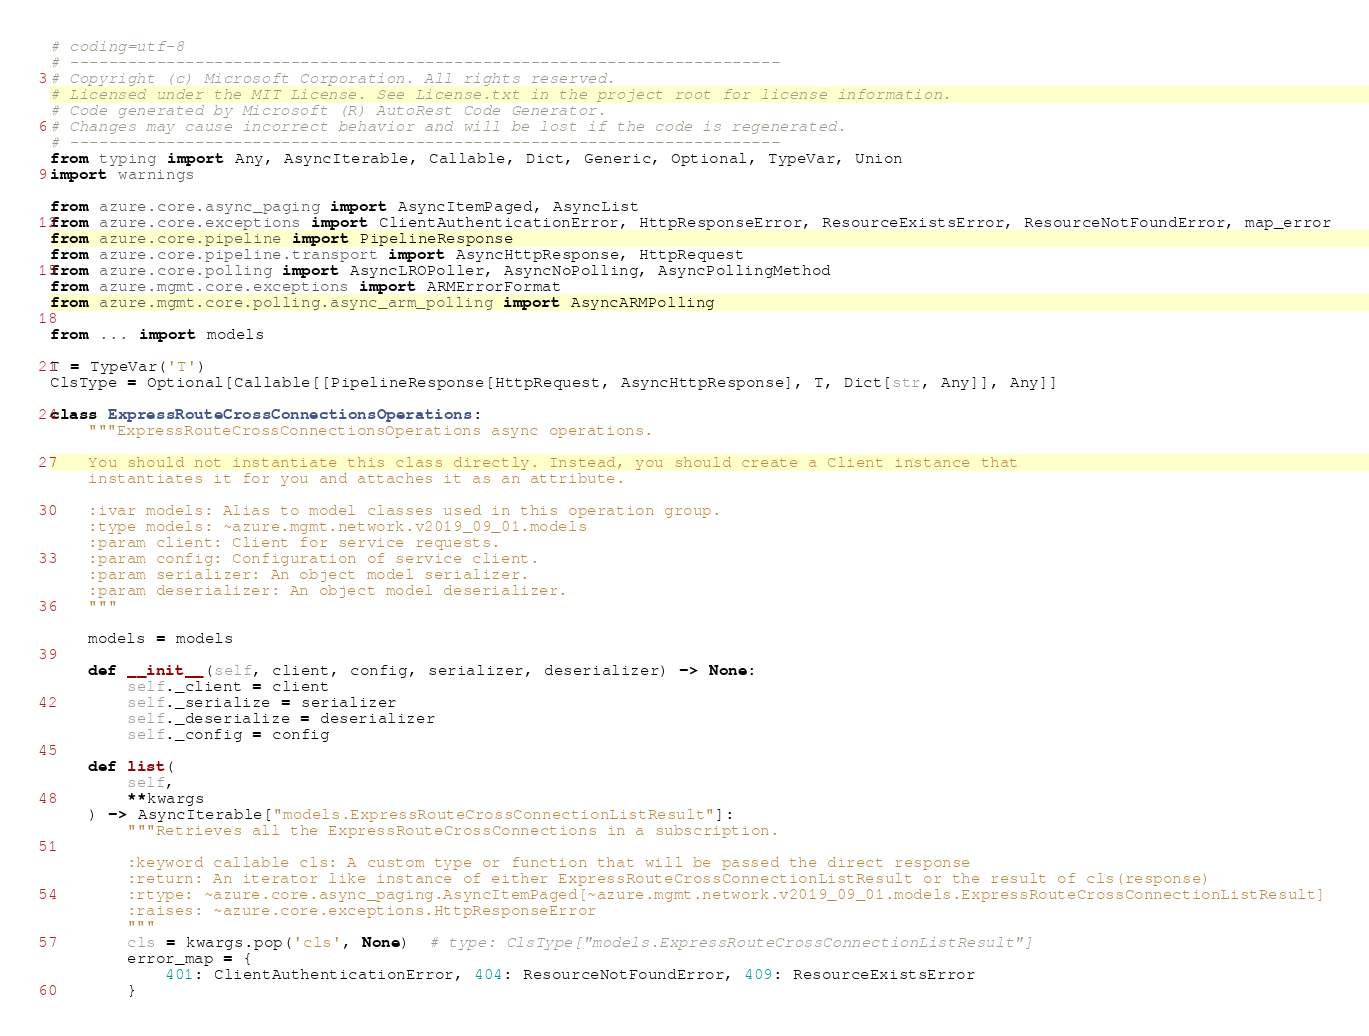<code> <loc_0><loc_0><loc_500><loc_500><_Python_># coding=utf-8
# --------------------------------------------------------------------------
# Copyright (c) Microsoft Corporation. All rights reserved.
# Licensed under the MIT License. See License.txt in the project root for license information.
# Code generated by Microsoft (R) AutoRest Code Generator.
# Changes may cause incorrect behavior and will be lost if the code is regenerated.
# --------------------------------------------------------------------------
from typing import Any, AsyncIterable, Callable, Dict, Generic, Optional, TypeVar, Union
import warnings

from azure.core.async_paging import AsyncItemPaged, AsyncList
from azure.core.exceptions import ClientAuthenticationError, HttpResponseError, ResourceExistsError, ResourceNotFoundError, map_error
from azure.core.pipeline import PipelineResponse
from azure.core.pipeline.transport import AsyncHttpResponse, HttpRequest
from azure.core.polling import AsyncLROPoller, AsyncNoPolling, AsyncPollingMethod
from azure.mgmt.core.exceptions import ARMErrorFormat
from azure.mgmt.core.polling.async_arm_polling import AsyncARMPolling

from ... import models

T = TypeVar('T')
ClsType = Optional[Callable[[PipelineResponse[HttpRequest, AsyncHttpResponse], T, Dict[str, Any]], Any]]

class ExpressRouteCrossConnectionsOperations:
    """ExpressRouteCrossConnectionsOperations async operations.

    You should not instantiate this class directly. Instead, you should create a Client instance that
    instantiates it for you and attaches it as an attribute.

    :ivar models: Alias to model classes used in this operation group.
    :type models: ~azure.mgmt.network.v2019_09_01.models
    :param client: Client for service requests.
    :param config: Configuration of service client.
    :param serializer: An object model serializer.
    :param deserializer: An object model deserializer.
    """

    models = models

    def __init__(self, client, config, serializer, deserializer) -> None:
        self._client = client
        self._serialize = serializer
        self._deserialize = deserializer
        self._config = config

    def list(
        self,
        **kwargs
    ) -> AsyncIterable["models.ExpressRouteCrossConnectionListResult"]:
        """Retrieves all the ExpressRouteCrossConnections in a subscription.

        :keyword callable cls: A custom type or function that will be passed the direct response
        :return: An iterator like instance of either ExpressRouteCrossConnectionListResult or the result of cls(response)
        :rtype: ~azure.core.async_paging.AsyncItemPaged[~azure.mgmt.network.v2019_09_01.models.ExpressRouteCrossConnectionListResult]
        :raises: ~azure.core.exceptions.HttpResponseError
        """
        cls = kwargs.pop('cls', None)  # type: ClsType["models.ExpressRouteCrossConnectionListResult"]
        error_map = {
            401: ClientAuthenticationError, 404: ResourceNotFoundError, 409: ResourceExistsError
        }</code> 